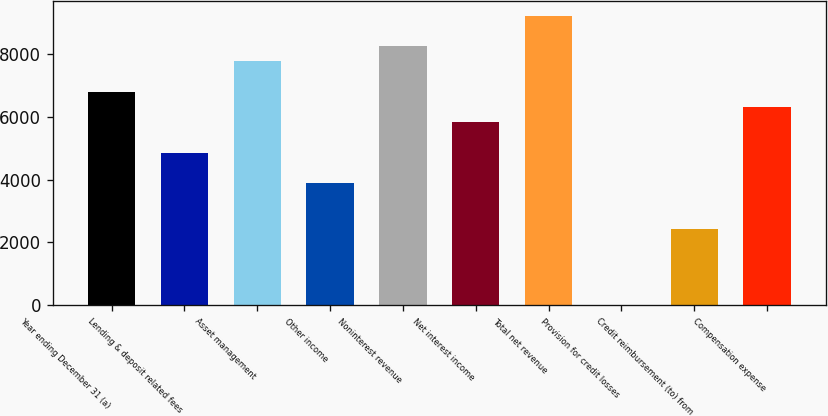<chart> <loc_0><loc_0><loc_500><loc_500><bar_chart><fcel>Year ending December 31 (a)<fcel>Lending & deposit related fees<fcel>Asset management<fcel>Other income<fcel>Noninterest revenue<fcel>Net interest income<fcel>Total net revenue<fcel>Provision for credit losses<fcel>Credit reimbursement (to) from<fcel>Compensation expense<nl><fcel>6797<fcel>4857<fcel>7767<fcel>3887<fcel>8252<fcel>5827<fcel>9222<fcel>7<fcel>2432<fcel>6312<nl></chart> 